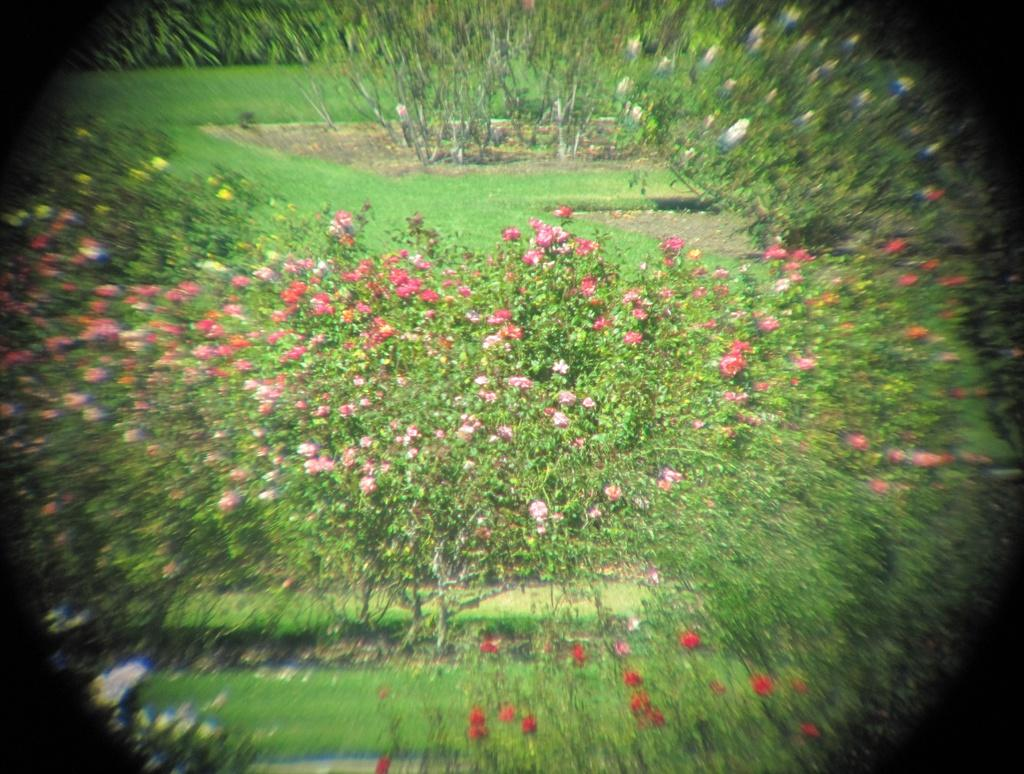What type of vegetation can be seen in the image? There are plants and flowers in the image. What is the ground covered with in the image? There is grass in the image. How many eyes can be seen on the flowers in the image? Flowers do not have eyes, so this detail cannot be observed in the image. 